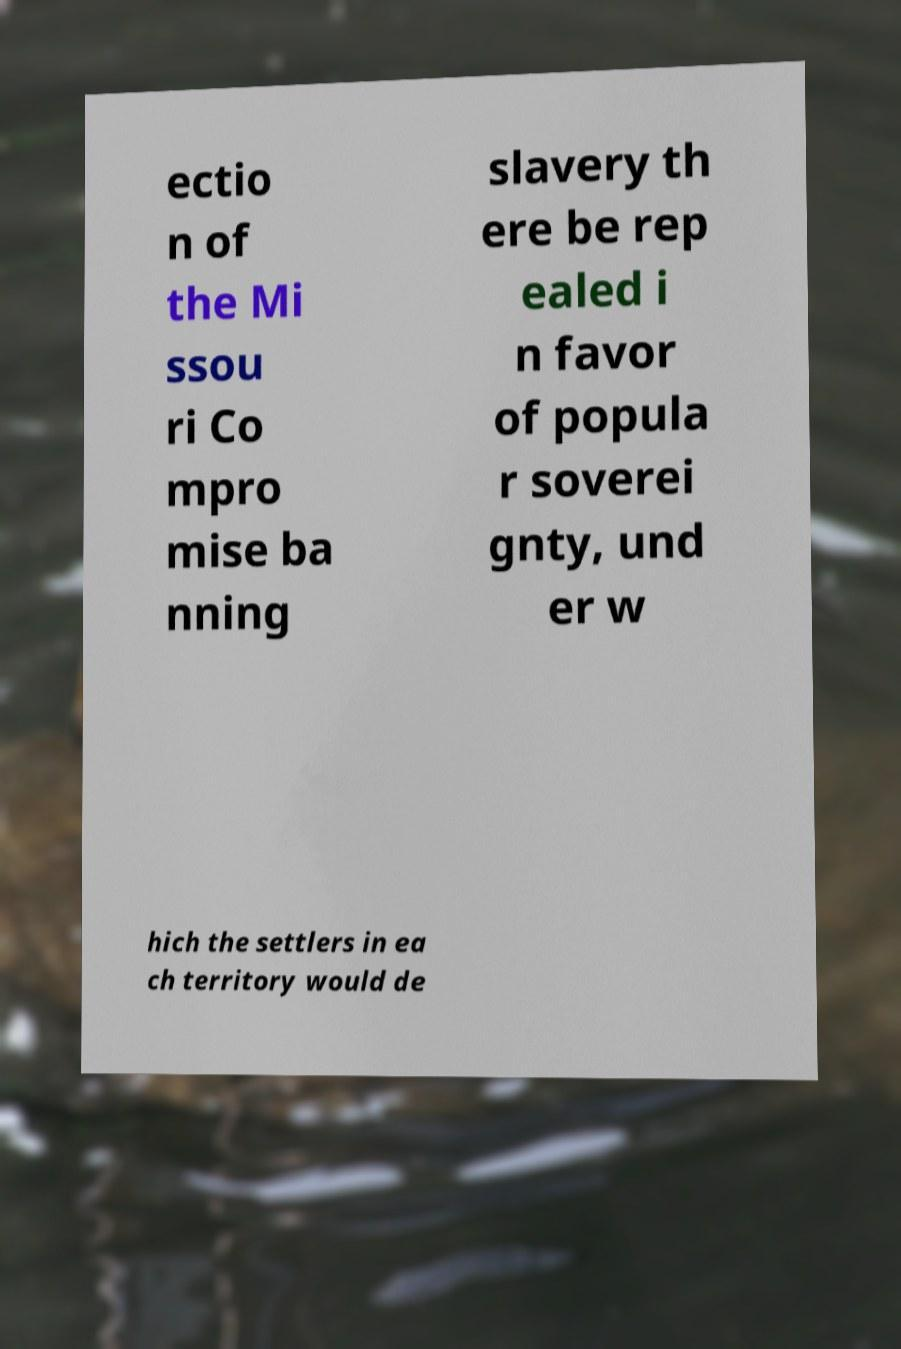Can you accurately transcribe the text from the provided image for me? ectio n of the Mi ssou ri Co mpro mise ba nning slavery th ere be rep ealed i n favor of popula r soverei gnty, und er w hich the settlers in ea ch territory would de 